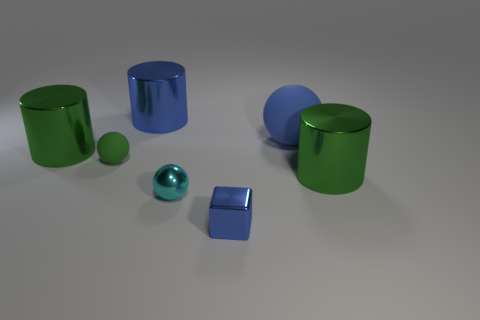What is the size of the metal block that is the same color as the large matte sphere?
Offer a terse response. Small. What is the shape of the big rubber thing that is the same color as the metal cube?
Provide a succinct answer. Sphere. What is the shape of the blue thing that is the same material as the small blue block?
Your response must be concise. Cylinder. Are there any small matte objects to the right of the small cyan metallic thing?
Your answer should be very brief. No. Is the number of large blue spheres to the left of the small blue metal object less than the number of green rubber things?
Provide a short and direct response. Yes. What is the material of the small green thing?
Offer a terse response. Rubber. What color is the metallic sphere?
Your response must be concise. Cyan. There is a large object that is right of the small block and behind the tiny green rubber object; what is its color?
Offer a terse response. Blue. Is there anything else that has the same material as the blue block?
Make the answer very short. Yes. Are the blue ball and the big green cylinder on the right side of the shiny cube made of the same material?
Ensure brevity in your answer.  No. 